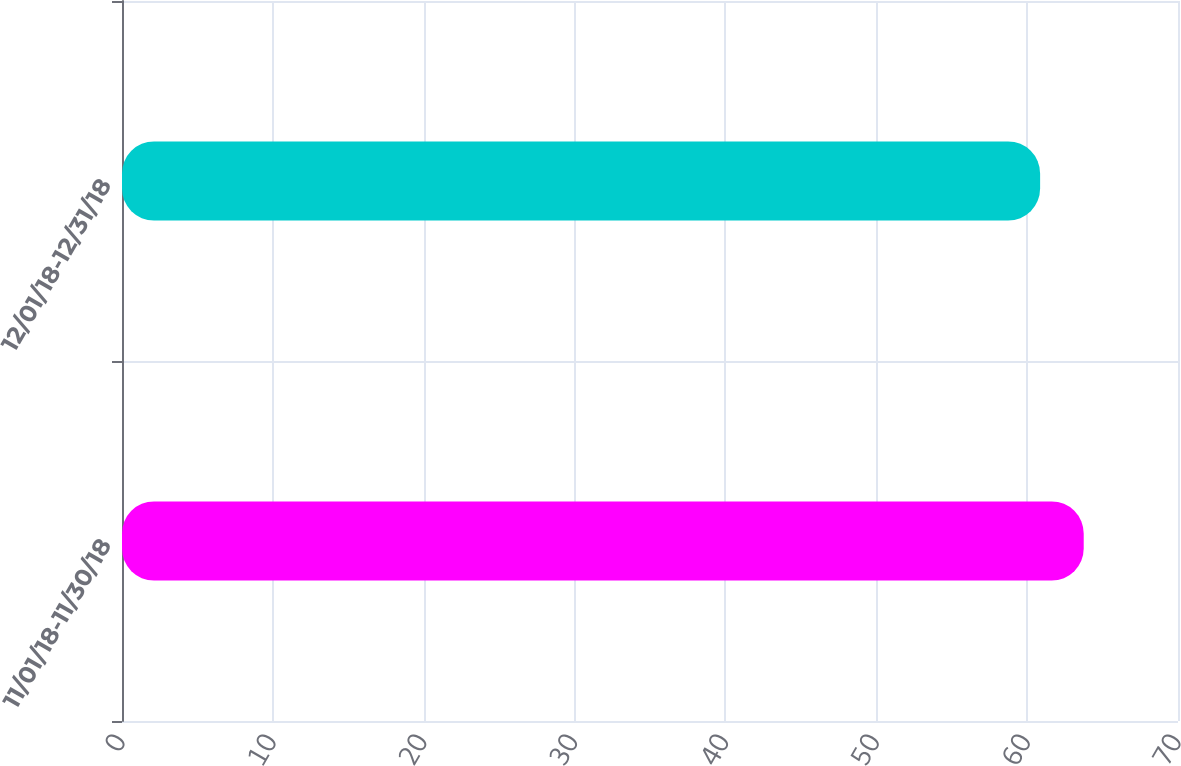Convert chart to OTSL. <chart><loc_0><loc_0><loc_500><loc_500><bar_chart><fcel>11/01/18-11/30/18<fcel>12/01/18-12/31/18<nl><fcel>63.75<fcel>60.86<nl></chart> 